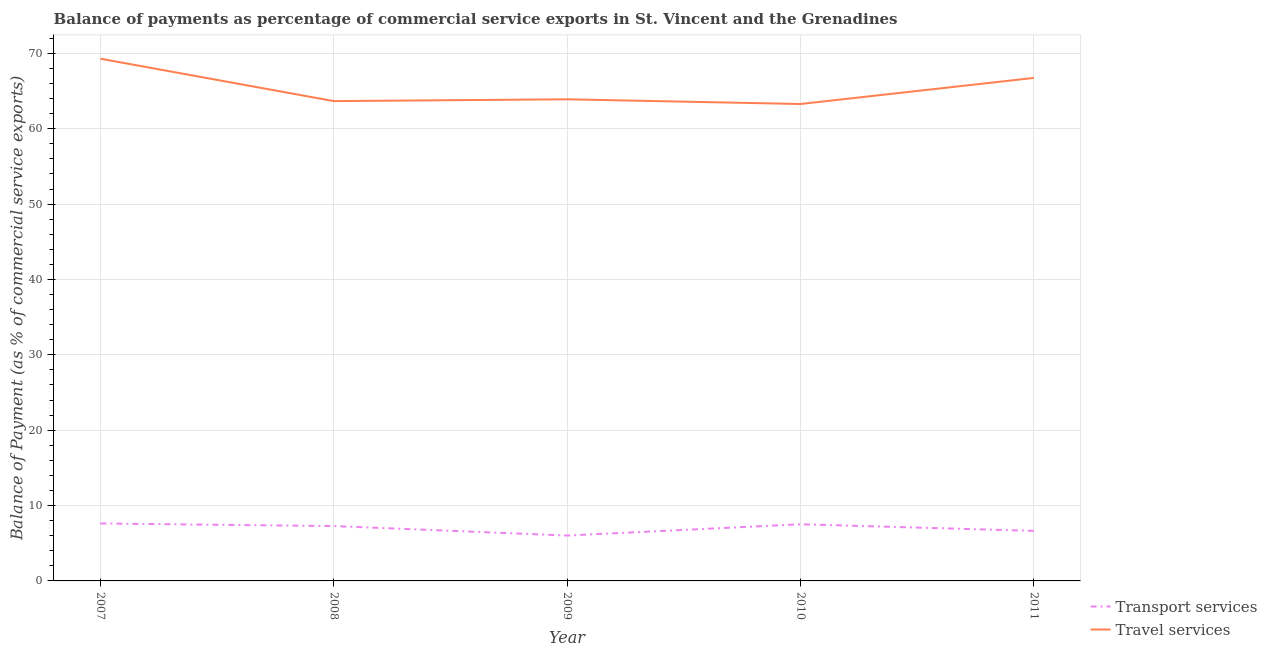How many different coloured lines are there?
Ensure brevity in your answer.  2. Does the line corresponding to balance of payments of travel services intersect with the line corresponding to balance of payments of transport services?
Provide a succinct answer. No. What is the balance of payments of travel services in 2009?
Offer a very short reply. 63.91. Across all years, what is the maximum balance of payments of travel services?
Your answer should be very brief. 69.29. Across all years, what is the minimum balance of payments of travel services?
Provide a succinct answer. 63.28. In which year was the balance of payments of transport services minimum?
Provide a succinct answer. 2009. What is the total balance of payments of travel services in the graph?
Give a very brief answer. 326.9. What is the difference between the balance of payments of travel services in 2008 and that in 2010?
Your answer should be very brief. 0.39. What is the difference between the balance of payments of travel services in 2010 and the balance of payments of transport services in 2009?
Your response must be concise. 57.26. What is the average balance of payments of travel services per year?
Offer a very short reply. 65.38. In the year 2011, what is the difference between the balance of payments of travel services and balance of payments of transport services?
Your answer should be very brief. 60.11. What is the ratio of the balance of payments of travel services in 2008 to that in 2011?
Keep it short and to the point. 0.95. What is the difference between the highest and the second highest balance of payments of travel services?
Make the answer very short. 2.55. What is the difference between the highest and the lowest balance of payments of transport services?
Your answer should be very brief. 1.6. In how many years, is the balance of payments of travel services greater than the average balance of payments of travel services taken over all years?
Make the answer very short. 2. Is the sum of the balance of payments of travel services in 2008 and 2010 greater than the maximum balance of payments of transport services across all years?
Provide a succinct answer. Yes. Is the balance of payments of travel services strictly greater than the balance of payments of transport services over the years?
Provide a succinct answer. Yes. Is the balance of payments of transport services strictly less than the balance of payments of travel services over the years?
Your answer should be compact. Yes. How many legend labels are there?
Offer a terse response. 2. What is the title of the graph?
Give a very brief answer. Balance of payments as percentage of commercial service exports in St. Vincent and the Grenadines. What is the label or title of the Y-axis?
Ensure brevity in your answer.  Balance of Payment (as % of commercial service exports). What is the Balance of Payment (as % of commercial service exports) of Transport services in 2007?
Offer a terse response. 7.62. What is the Balance of Payment (as % of commercial service exports) in Travel services in 2007?
Give a very brief answer. 69.29. What is the Balance of Payment (as % of commercial service exports) of Transport services in 2008?
Your response must be concise. 7.28. What is the Balance of Payment (as % of commercial service exports) in Travel services in 2008?
Offer a terse response. 63.67. What is the Balance of Payment (as % of commercial service exports) in Transport services in 2009?
Give a very brief answer. 6.02. What is the Balance of Payment (as % of commercial service exports) of Travel services in 2009?
Provide a short and direct response. 63.91. What is the Balance of Payment (as % of commercial service exports) in Transport services in 2010?
Your answer should be compact. 7.52. What is the Balance of Payment (as % of commercial service exports) of Travel services in 2010?
Offer a terse response. 63.28. What is the Balance of Payment (as % of commercial service exports) in Transport services in 2011?
Make the answer very short. 6.64. What is the Balance of Payment (as % of commercial service exports) in Travel services in 2011?
Give a very brief answer. 66.75. Across all years, what is the maximum Balance of Payment (as % of commercial service exports) of Transport services?
Your response must be concise. 7.62. Across all years, what is the maximum Balance of Payment (as % of commercial service exports) of Travel services?
Your response must be concise. 69.29. Across all years, what is the minimum Balance of Payment (as % of commercial service exports) in Transport services?
Keep it short and to the point. 6.02. Across all years, what is the minimum Balance of Payment (as % of commercial service exports) of Travel services?
Offer a very short reply. 63.28. What is the total Balance of Payment (as % of commercial service exports) of Transport services in the graph?
Offer a very short reply. 35.09. What is the total Balance of Payment (as % of commercial service exports) in Travel services in the graph?
Provide a short and direct response. 326.9. What is the difference between the Balance of Payment (as % of commercial service exports) of Transport services in 2007 and that in 2008?
Provide a succinct answer. 0.35. What is the difference between the Balance of Payment (as % of commercial service exports) in Travel services in 2007 and that in 2008?
Provide a short and direct response. 5.62. What is the difference between the Balance of Payment (as % of commercial service exports) in Transport services in 2007 and that in 2009?
Give a very brief answer. 1.6. What is the difference between the Balance of Payment (as % of commercial service exports) in Travel services in 2007 and that in 2009?
Make the answer very short. 5.39. What is the difference between the Balance of Payment (as % of commercial service exports) in Transport services in 2007 and that in 2010?
Make the answer very short. 0.1. What is the difference between the Balance of Payment (as % of commercial service exports) in Travel services in 2007 and that in 2010?
Provide a succinct answer. 6.01. What is the difference between the Balance of Payment (as % of commercial service exports) in Transport services in 2007 and that in 2011?
Provide a short and direct response. 0.98. What is the difference between the Balance of Payment (as % of commercial service exports) of Travel services in 2007 and that in 2011?
Give a very brief answer. 2.55. What is the difference between the Balance of Payment (as % of commercial service exports) in Transport services in 2008 and that in 2009?
Your response must be concise. 1.26. What is the difference between the Balance of Payment (as % of commercial service exports) in Travel services in 2008 and that in 2009?
Provide a short and direct response. -0.24. What is the difference between the Balance of Payment (as % of commercial service exports) in Transport services in 2008 and that in 2010?
Your answer should be compact. -0.24. What is the difference between the Balance of Payment (as % of commercial service exports) in Travel services in 2008 and that in 2010?
Ensure brevity in your answer.  0.39. What is the difference between the Balance of Payment (as % of commercial service exports) in Transport services in 2008 and that in 2011?
Provide a short and direct response. 0.64. What is the difference between the Balance of Payment (as % of commercial service exports) in Travel services in 2008 and that in 2011?
Provide a short and direct response. -3.08. What is the difference between the Balance of Payment (as % of commercial service exports) of Transport services in 2009 and that in 2010?
Offer a terse response. -1.5. What is the difference between the Balance of Payment (as % of commercial service exports) in Travel services in 2009 and that in 2010?
Your answer should be compact. 0.62. What is the difference between the Balance of Payment (as % of commercial service exports) in Transport services in 2009 and that in 2011?
Keep it short and to the point. -0.62. What is the difference between the Balance of Payment (as % of commercial service exports) in Travel services in 2009 and that in 2011?
Offer a very short reply. -2.84. What is the difference between the Balance of Payment (as % of commercial service exports) of Transport services in 2010 and that in 2011?
Offer a very short reply. 0.88. What is the difference between the Balance of Payment (as % of commercial service exports) of Travel services in 2010 and that in 2011?
Ensure brevity in your answer.  -3.46. What is the difference between the Balance of Payment (as % of commercial service exports) of Transport services in 2007 and the Balance of Payment (as % of commercial service exports) of Travel services in 2008?
Provide a short and direct response. -56.05. What is the difference between the Balance of Payment (as % of commercial service exports) of Transport services in 2007 and the Balance of Payment (as % of commercial service exports) of Travel services in 2009?
Keep it short and to the point. -56.28. What is the difference between the Balance of Payment (as % of commercial service exports) of Transport services in 2007 and the Balance of Payment (as % of commercial service exports) of Travel services in 2010?
Your answer should be compact. -55.66. What is the difference between the Balance of Payment (as % of commercial service exports) in Transport services in 2007 and the Balance of Payment (as % of commercial service exports) in Travel services in 2011?
Offer a terse response. -59.12. What is the difference between the Balance of Payment (as % of commercial service exports) of Transport services in 2008 and the Balance of Payment (as % of commercial service exports) of Travel services in 2009?
Your answer should be compact. -56.63. What is the difference between the Balance of Payment (as % of commercial service exports) of Transport services in 2008 and the Balance of Payment (as % of commercial service exports) of Travel services in 2010?
Offer a terse response. -56.01. What is the difference between the Balance of Payment (as % of commercial service exports) in Transport services in 2008 and the Balance of Payment (as % of commercial service exports) in Travel services in 2011?
Keep it short and to the point. -59.47. What is the difference between the Balance of Payment (as % of commercial service exports) in Transport services in 2009 and the Balance of Payment (as % of commercial service exports) in Travel services in 2010?
Provide a succinct answer. -57.26. What is the difference between the Balance of Payment (as % of commercial service exports) in Transport services in 2009 and the Balance of Payment (as % of commercial service exports) in Travel services in 2011?
Your answer should be very brief. -60.73. What is the difference between the Balance of Payment (as % of commercial service exports) in Transport services in 2010 and the Balance of Payment (as % of commercial service exports) in Travel services in 2011?
Make the answer very short. -59.23. What is the average Balance of Payment (as % of commercial service exports) in Transport services per year?
Offer a very short reply. 7.02. What is the average Balance of Payment (as % of commercial service exports) in Travel services per year?
Offer a terse response. 65.38. In the year 2007, what is the difference between the Balance of Payment (as % of commercial service exports) in Transport services and Balance of Payment (as % of commercial service exports) in Travel services?
Ensure brevity in your answer.  -61.67. In the year 2008, what is the difference between the Balance of Payment (as % of commercial service exports) of Transport services and Balance of Payment (as % of commercial service exports) of Travel services?
Your answer should be compact. -56.39. In the year 2009, what is the difference between the Balance of Payment (as % of commercial service exports) of Transport services and Balance of Payment (as % of commercial service exports) of Travel services?
Provide a succinct answer. -57.89. In the year 2010, what is the difference between the Balance of Payment (as % of commercial service exports) of Transport services and Balance of Payment (as % of commercial service exports) of Travel services?
Provide a succinct answer. -55.76. In the year 2011, what is the difference between the Balance of Payment (as % of commercial service exports) in Transport services and Balance of Payment (as % of commercial service exports) in Travel services?
Give a very brief answer. -60.11. What is the ratio of the Balance of Payment (as % of commercial service exports) in Transport services in 2007 to that in 2008?
Provide a short and direct response. 1.05. What is the ratio of the Balance of Payment (as % of commercial service exports) of Travel services in 2007 to that in 2008?
Give a very brief answer. 1.09. What is the ratio of the Balance of Payment (as % of commercial service exports) of Transport services in 2007 to that in 2009?
Your response must be concise. 1.27. What is the ratio of the Balance of Payment (as % of commercial service exports) in Travel services in 2007 to that in 2009?
Ensure brevity in your answer.  1.08. What is the ratio of the Balance of Payment (as % of commercial service exports) in Transport services in 2007 to that in 2010?
Make the answer very short. 1.01. What is the ratio of the Balance of Payment (as % of commercial service exports) in Travel services in 2007 to that in 2010?
Make the answer very short. 1.09. What is the ratio of the Balance of Payment (as % of commercial service exports) in Transport services in 2007 to that in 2011?
Provide a succinct answer. 1.15. What is the ratio of the Balance of Payment (as % of commercial service exports) of Travel services in 2007 to that in 2011?
Your answer should be very brief. 1.04. What is the ratio of the Balance of Payment (as % of commercial service exports) of Transport services in 2008 to that in 2009?
Give a very brief answer. 1.21. What is the ratio of the Balance of Payment (as % of commercial service exports) of Travel services in 2008 to that in 2009?
Your response must be concise. 1. What is the ratio of the Balance of Payment (as % of commercial service exports) of Travel services in 2008 to that in 2010?
Provide a succinct answer. 1.01. What is the ratio of the Balance of Payment (as % of commercial service exports) of Transport services in 2008 to that in 2011?
Provide a succinct answer. 1.1. What is the ratio of the Balance of Payment (as % of commercial service exports) in Travel services in 2008 to that in 2011?
Provide a short and direct response. 0.95. What is the ratio of the Balance of Payment (as % of commercial service exports) of Transport services in 2009 to that in 2010?
Keep it short and to the point. 0.8. What is the ratio of the Balance of Payment (as % of commercial service exports) of Travel services in 2009 to that in 2010?
Keep it short and to the point. 1.01. What is the ratio of the Balance of Payment (as % of commercial service exports) of Transport services in 2009 to that in 2011?
Your response must be concise. 0.91. What is the ratio of the Balance of Payment (as % of commercial service exports) in Travel services in 2009 to that in 2011?
Offer a very short reply. 0.96. What is the ratio of the Balance of Payment (as % of commercial service exports) in Transport services in 2010 to that in 2011?
Ensure brevity in your answer.  1.13. What is the ratio of the Balance of Payment (as % of commercial service exports) in Travel services in 2010 to that in 2011?
Keep it short and to the point. 0.95. What is the difference between the highest and the second highest Balance of Payment (as % of commercial service exports) in Transport services?
Provide a succinct answer. 0.1. What is the difference between the highest and the second highest Balance of Payment (as % of commercial service exports) in Travel services?
Provide a short and direct response. 2.55. What is the difference between the highest and the lowest Balance of Payment (as % of commercial service exports) in Transport services?
Give a very brief answer. 1.6. What is the difference between the highest and the lowest Balance of Payment (as % of commercial service exports) in Travel services?
Provide a short and direct response. 6.01. 